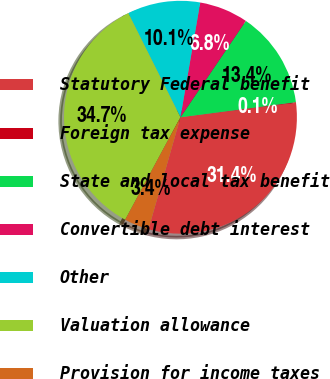Convert chart. <chart><loc_0><loc_0><loc_500><loc_500><pie_chart><fcel>Statutory Federal benefit<fcel>Foreign tax expense<fcel>State and local tax benefit<fcel>Convertible debt interest<fcel>Other<fcel>Valuation allowance<fcel>Provision for income taxes<nl><fcel>31.4%<fcel>0.1%<fcel>13.44%<fcel>6.77%<fcel>10.11%<fcel>34.74%<fcel>3.44%<nl></chart> 